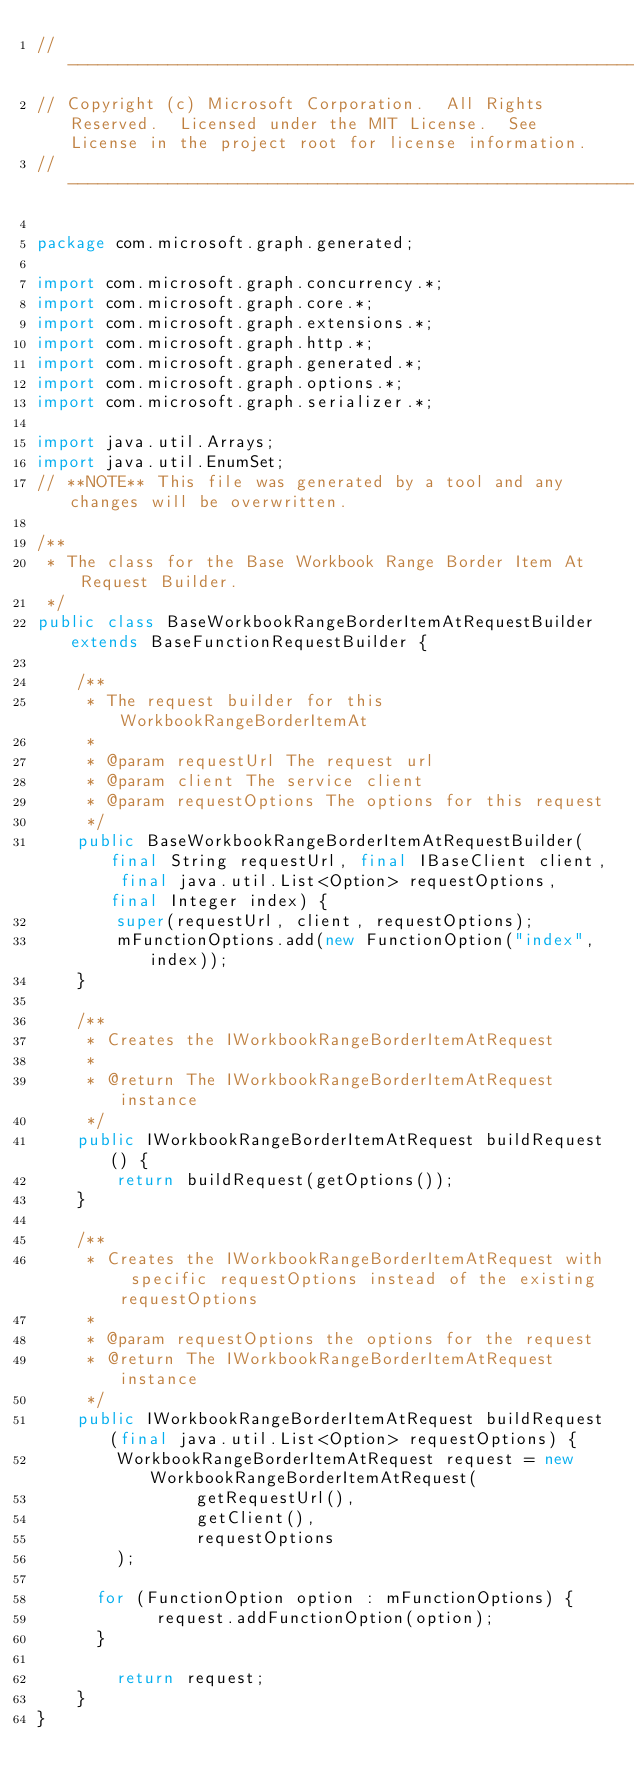Convert code to text. <code><loc_0><loc_0><loc_500><loc_500><_Java_>// ------------------------------------------------------------------------------
// Copyright (c) Microsoft Corporation.  All Rights Reserved.  Licensed under the MIT License.  See License in the project root for license information.
// ------------------------------------------------------------------------------

package com.microsoft.graph.generated;

import com.microsoft.graph.concurrency.*;
import com.microsoft.graph.core.*;
import com.microsoft.graph.extensions.*;
import com.microsoft.graph.http.*;
import com.microsoft.graph.generated.*;
import com.microsoft.graph.options.*;
import com.microsoft.graph.serializer.*;

import java.util.Arrays;
import java.util.EnumSet;
// **NOTE** This file was generated by a tool and any changes will be overwritten.

/**
 * The class for the Base Workbook Range Border Item At Request Builder.
 */
public class BaseWorkbookRangeBorderItemAtRequestBuilder extends BaseFunctionRequestBuilder {

    /**
     * The request builder for this WorkbookRangeBorderItemAt
     *
     * @param requestUrl The request url
     * @param client The service client
     * @param requestOptions The options for this request
     */
    public BaseWorkbookRangeBorderItemAtRequestBuilder(final String requestUrl, final IBaseClient client, final java.util.List<Option> requestOptions, final Integer index) {
        super(requestUrl, client, requestOptions);
        mFunctionOptions.add(new FunctionOption("index", index));
    }

    /**
     * Creates the IWorkbookRangeBorderItemAtRequest
     *
     * @return The IWorkbookRangeBorderItemAtRequest instance
     */
    public IWorkbookRangeBorderItemAtRequest buildRequest() {
        return buildRequest(getOptions());
    }

    /**
     * Creates the IWorkbookRangeBorderItemAtRequest with specific requestOptions instead of the existing requestOptions
     *
     * @param requestOptions the options for the request
     * @return The IWorkbookRangeBorderItemAtRequest instance
     */
    public IWorkbookRangeBorderItemAtRequest buildRequest(final java.util.List<Option> requestOptions) {
        WorkbookRangeBorderItemAtRequest request = new WorkbookRangeBorderItemAtRequest(
                getRequestUrl(),
                getClient(),
                requestOptions
        );

      for (FunctionOption option : mFunctionOptions) {
            request.addFunctionOption(option);
      }

        return request;
    }
}
</code> 